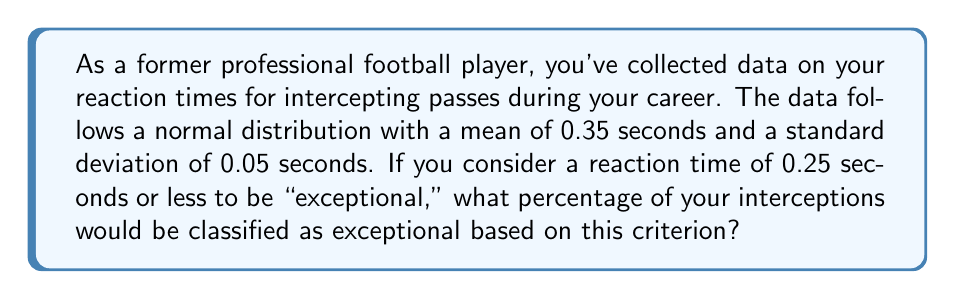Show me your answer to this math problem. Let's approach this step-by-step:

1) We're dealing with a normal distribution where:
   $\mu = 0.35$ seconds (mean)
   $\sigma = 0.05$ seconds (standard deviation)

2) We want to find the probability of a reaction time $\leq 0.25$ seconds.

3) To do this, we need to calculate the z-score for 0.25 seconds:

   $$z = \frac{x - \mu}{\sigma} = \frac{0.25 - 0.35}{0.05} = -2$$

4) This z-score of -2 means that 0.25 seconds is 2 standard deviations below the mean.

5) Using a standard normal distribution table or calculator, we can find that the area to the left of z = -2 is approximately 0.0228.

6) This means that about 2.28% of the reaction times are 0.25 seconds or less.

7) Therefore, 2.28% of your interceptions would be classified as exceptional based on this criterion.
Answer: 2.28% 